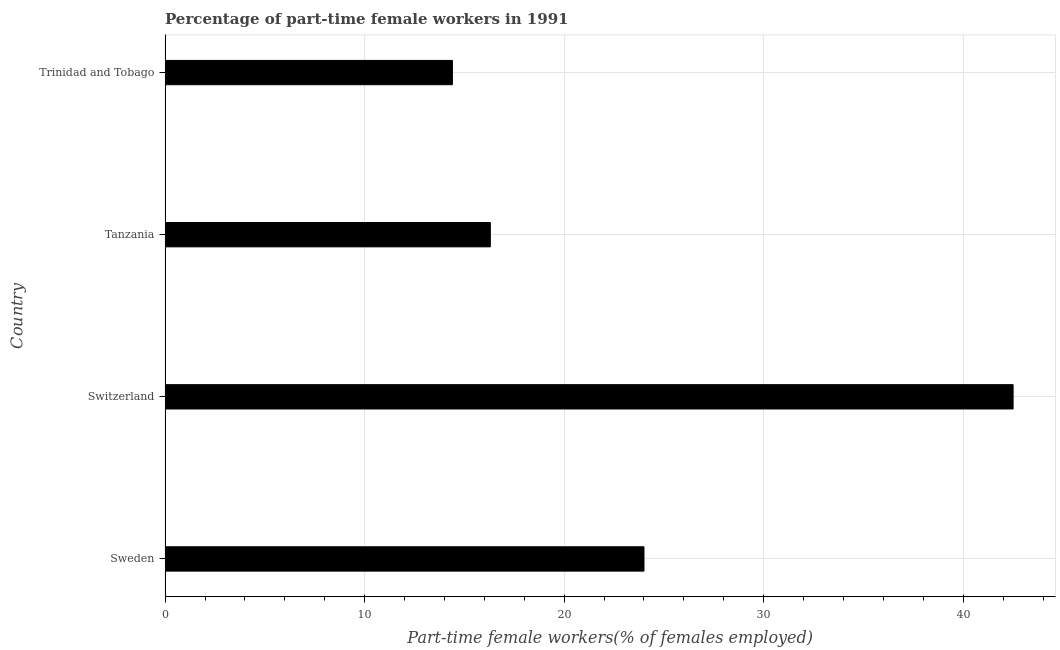What is the title of the graph?
Make the answer very short. Percentage of part-time female workers in 1991. What is the label or title of the X-axis?
Keep it short and to the point. Part-time female workers(% of females employed). What is the label or title of the Y-axis?
Make the answer very short. Country. What is the percentage of part-time female workers in Trinidad and Tobago?
Give a very brief answer. 14.4. Across all countries, what is the maximum percentage of part-time female workers?
Provide a short and direct response. 42.5. Across all countries, what is the minimum percentage of part-time female workers?
Ensure brevity in your answer.  14.4. In which country was the percentage of part-time female workers maximum?
Make the answer very short. Switzerland. In which country was the percentage of part-time female workers minimum?
Keep it short and to the point. Trinidad and Tobago. What is the sum of the percentage of part-time female workers?
Provide a short and direct response. 97.2. What is the difference between the percentage of part-time female workers in Switzerland and Trinidad and Tobago?
Give a very brief answer. 28.1. What is the average percentage of part-time female workers per country?
Ensure brevity in your answer.  24.3. What is the median percentage of part-time female workers?
Offer a terse response. 20.15. In how many countries, is the percentage of part-time female workers greater than 8 %?
Make the answer very short. 4. What is the ratio of the percentage of part-time female workers in Sweden to that in Switzerland?
Offer a very short reply. 0.56. Is the sum of the percentage of part-time female workers in Sweden and Switzerland greater than the maximum percentage of part-time female workers across all countries?
Provide a succinct answer. Yes. What is the difference between the highest and the lowest percentage of part-time female workers?
Give a very brief answer. 28.1. Are all the bars in the graph horizontal?
Give a very brief answer. Yes. What is the Part-time female workers(% of females employed) in Switzerland?
Keep it short and to the point. 42.5. What is the Part-time female workers(% of females employed) in Tanzania?
Your answer should be very brief. 16.3. What is the Part-time female workers(% of females employed) of Trinidad and Tobago?
Provide a succinct answer. 14.4. What is the difference between the Part-time female workers(% of females employed) in Sweden and Switzerland?
Provide a short and direct response. -18.5. What is the difference between the Part-time female workers(% of females employed) in Sweden and Tanzania?
Your answer should be very brief. 7.7. What is the difference between the Part-time female workers(% of females employed) in Switzerland and Tanzania?
Your answer should be very brief. 26.2. What is the difference between the Part-time female workers(% of females employed) in Switzerland and Trinidad and Tobago?
Your answer should be very brief. 28.1. What is the difference between the Part-time female workers(% of females employed) in Tanzania and Trinidad and Tobago?
Offer a terse response. 1.9. What is the ratio of the Part-time female workers(% of females employed) in Sweden to that in Switzerland?
Make the answer very short. 0.56. What is the ratio of the Part-time female workers(% of females employed) in Sweden to that in Tanzania?
Make the answer very short. 1.47. What is the ratio of the Part-time female workers(% of females employed) in Sweden to that in Trinidad and Tobago?
Ensure brevity in your answer.  1.67. What is the ratio of the Part-time female workers(% of females employed) in Switzerland to that in Tanzania?
Ensure brevity in your answer.  2.61. What is the ratio of the Part-time female workers(% of females employed) in Switzerland to that in Trinidad and Tobago?
Your answer should be compact. 2.95. What is the ratio of the Part-time female workers(% of females employed) in Tanzania to that in Trinidad and Tobago?
Your answer should be compact. 1.13. 